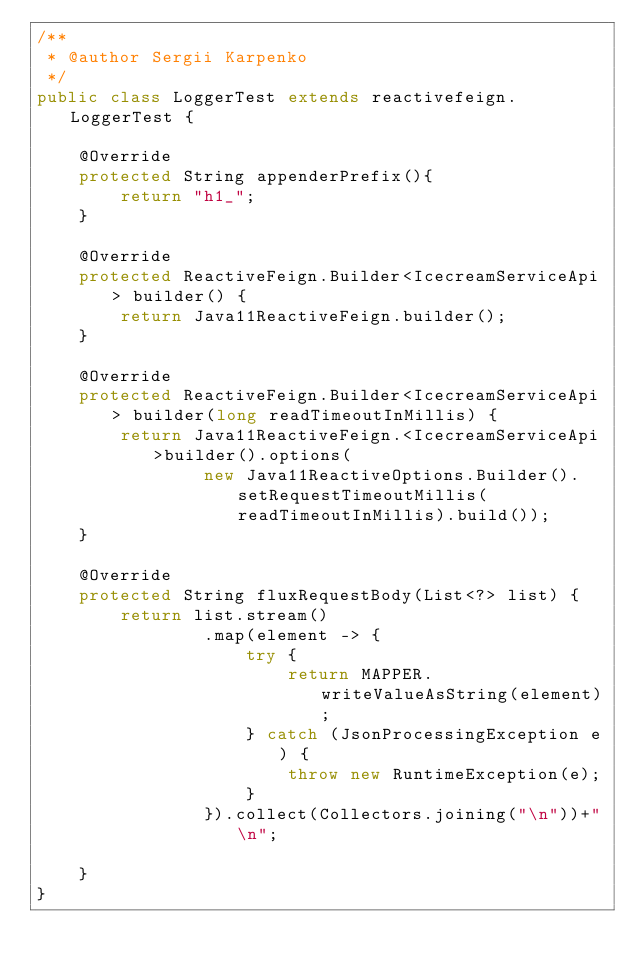Convert code to text. <code><loc_0><loc_0><loc_500><loc_500><_Java_>/**
 * @author Sergii Karpenko
 */
public class LoggerTest extends reactivefeign.LoggerTest {

    @Override
    protected String appenderPrefix(){
        return "h1_";
    }

    @Override
    protected ReactiveFeign.Builder<IcecreamServiceApi> builder() {
        return Java11ReactiveFeign.builder();
    }

    @Override
    protected ReactiveFeign.Builder<IcecreamServiceApi> builder(long readTimeoutInMillis) {
        return Java11ReactiveFeign.<IcecreamServiceApi>builder().options(
                new Java11ReactiveOptions.Builder().setRequestTimeoutMillis(readTimeoutInMillis).build());
    }

    @Override
    protected String fluxRequestBody(List<?> list) {
        return list.stream()
                .map(element -> {
                    try {
                        return MAPPER.writeValueAsString(element);
                    } catch (JsonProcessingException e) {
                        throw new RuntimeException(e);
                    }
                }).collect(Collectors.joining("\n"))+"\n";

    }
}
</code> 